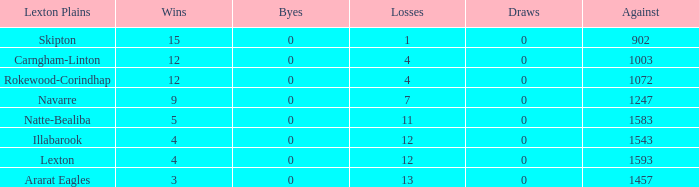Which team possesses under 9 wins and fewer than 1593 points against them? Natte-Bealiba, Illabarook, Ararat Eagles. 